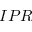<formula> <loc_0><loc_0><loc_500><loc_500>I P R</formula> 